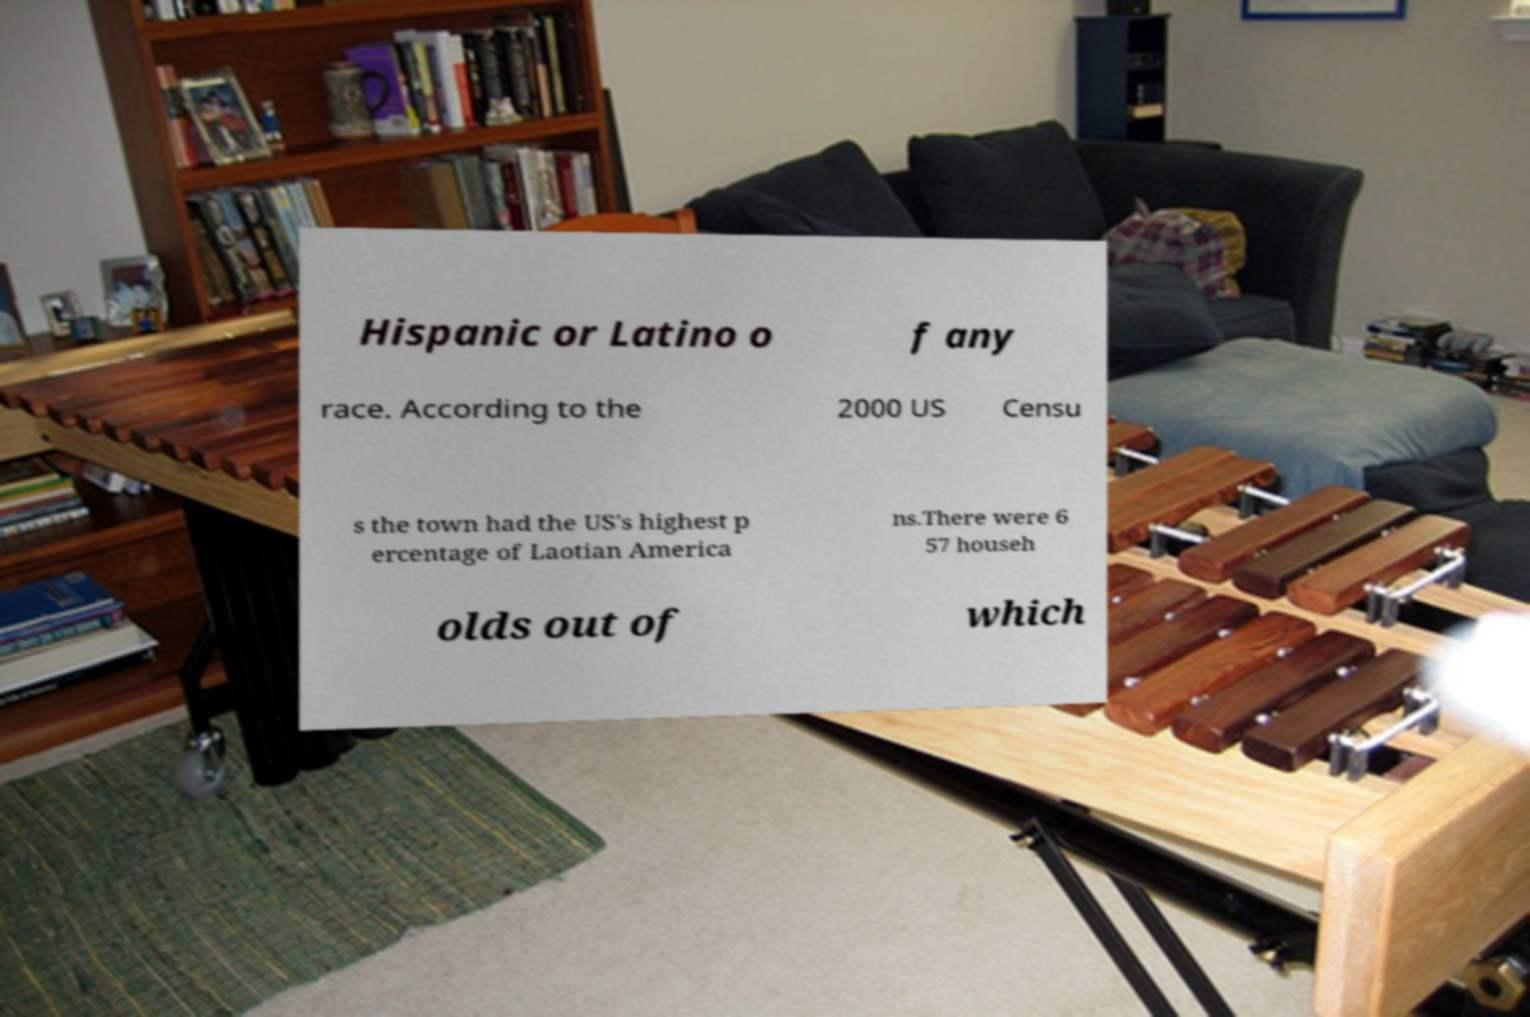Please identify and transcribe the text found in this image. Hispanic or Latino o f any race. According to the 2000 US Censu s the town had the US's highest p ercentage of Laotian America ns.There were 6 57 househ olds out of which 